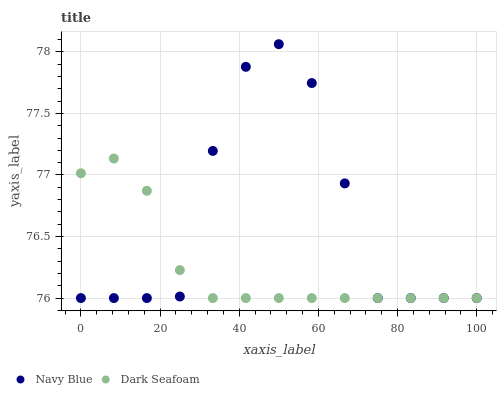Does Dark Seafoam have the minimum area under the curve?
Answer yes or no. Yes. Does Navy Blue have the maximum area under the curve?
Answer yes or no. Yes. Does Dark Seafoam have the maximum area under the curve?
Answer yes or no. No. Is Dark Seafoam the smoothest?
Answer yes or no. Yes. Is Navy Blue the roughest?
Answer yes or no. Yes. Is Dark Seafoam the roughest?
Answer yes or no. No. Does Navy Blue have the lowest value?
Answer yes or no. Yes. Does Navy Blue have the highest value?
Answer yes or no. Yes. Does Dark Seafoam have the highest value?
Answer yes or no. No. Does Dark Seafoam intersect Navy Blue?
Answer yes or no. Yes. Is Dark Seafoam less than Navy Blue?
Answer yes or no. No. Is Dark Seafoam greater than Navy Blue?
Answer yes or no. No. 